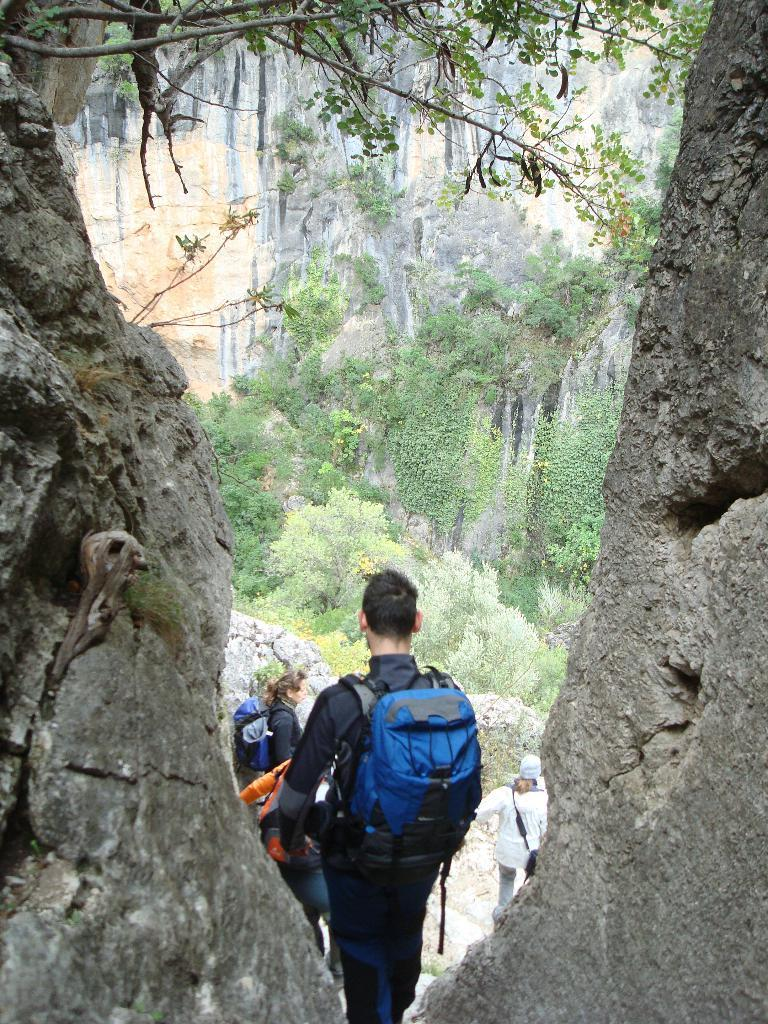What are the people in the image doing? There are people standing in the image. What are some of the people carrying? Some of the people are carrying bags. Can you describe the clothing of one of the people in the image? There is a person wearing a cap in the image. What is the size of the person's wrist in the image? There is no mention of a wrist in the image, so it cannot be determined. 